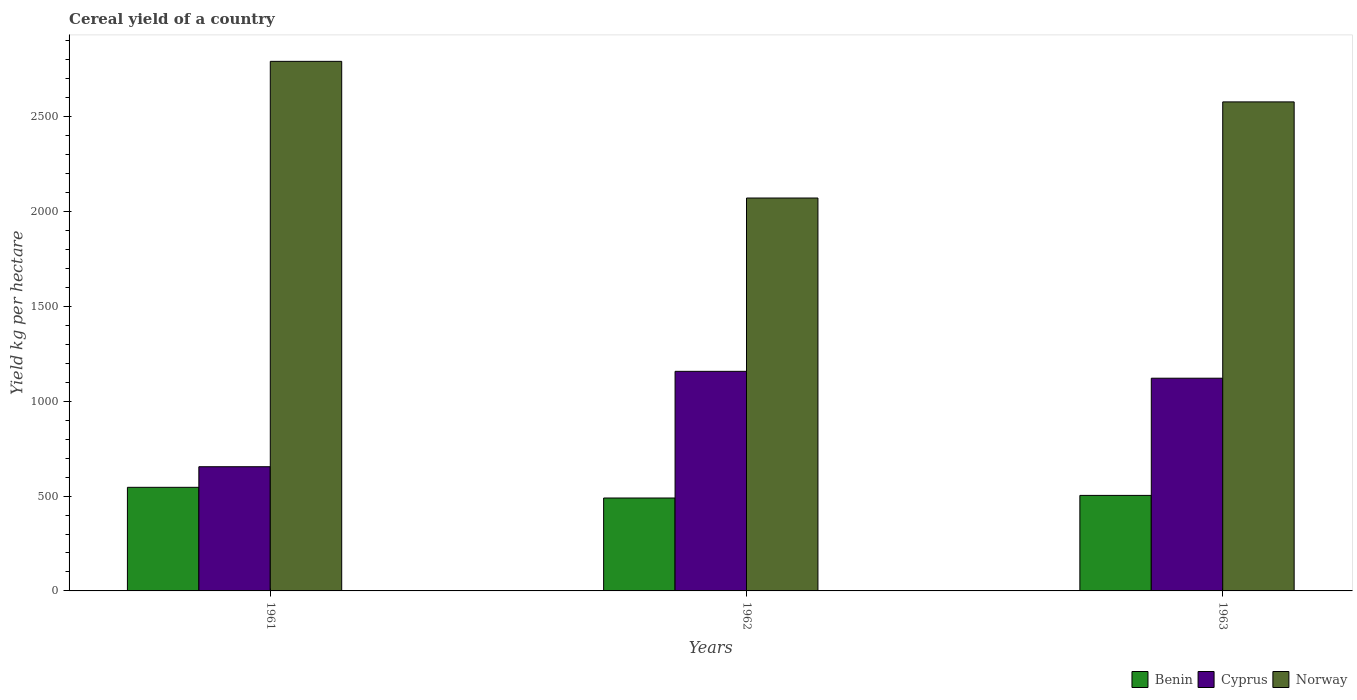How many different coloured bars are there?
Offer a very short reply. 3. Are the number of bars on each tick of the X-axis equal?
Offer a very short reply. Yes. How many bars are there on the 2nd tick from the left?
Your response must be concise. 3. What is the total cereal yield in Cyprus in 1962?
Your response must be concise. 1157.61. Across all years, what is the maximum total cereal yield in Norway?
Make the answer very short. 2791.78. Across all years, what is the minimum total cereal yield in Norway?
Ensure brevity in your answer.  2071.26. In which year was the total cereal yield in Cyprus maximum?
Provide a short and direct response. 1962. In which year was the total cereal yield in Benin minimum?
Offer a terse response. 1962. What is the total total cereal yield in Benin in the graph?
Give a very brief answer. 1539.53. What is the difference between the total cereal yield in Benin in 1961 and that in 1963?
Ensure brevity in your answer.  42.59. What is the difference between the total cereal yield in Benin in 1962 and the total cereal yield in Cyprus in 1963?
Offer a terse response. -631.47. What is the average total cereal yield in Norway per year?
Ensure brevity in your answer.  2480.37. In the year 1961, what is the difference between the total cereal yield in Benin and total cereal yield in Norway?
Offer a terse response. -2245.65. In how many years, is the total cereal yield in Cyprus greater than 1900 kg per hectare?
Offer a terse response. 0. What is the ratio of the total cereal yield in Benin in 1962 to that in 1963?
Your response must be concise. 0.97. Is the difference between the total cereal yield in Benin in 1962 and 1963 greater than the difference between the total cereal yield in Norway in 1962 and 1963?
Provide a succinct answer. Yes. What is the difference between the highest and the second highest total cereal yield in Benin?
Offer a terse response. 42.59. What is the difference between the highest and the lowest total cereal yield in Benin?
Provide a short and direct response. 56.27. In how many years, is the total cereal yield in Cyprus greater than the average total cereal yield in Cyprus taken over all years?
Make the answer very short. 2. Is the sum of the total cereal yield in Benin in 1961 and 1963 greater than the maximum total cereal yield in Norway across all years?
Provide a short and direct response. No. What does the 1st bar from the left in 1961 represents?
Provide a succinct answer. Benin. What does the 2nd bar from the right in 1962 represents?
Keep it short and to the point. Cyprus. Is it the case that in every year, the sum of the total cereal yield in Cyprus and total cereal yield in Benin is greater than the total cereal yield in Norway?
Ensure brevity in your answer.  No. How many bars are there?
Offer a terse response. 9. How many years are there in the graph?
Offer a very short reply. 3. Are the values on the major ticks of Y-axis written in scientific E-notation?
Provide a succinct answer. No. Does the graph contain grids?
Your answer should be compact. No. How many legend labels are there?
Your response must be concise. 3. What is the title of the graph?
Make the answer very short. Cereal yield of a country. What is the label or title of the X-axis?
Your answer should be very brief. Years. What is the label or title of the Y-axis?
Provide a succinct answer. Yield kg per hectare. What is the Yield kg per hectare of Benin in 1961?
Offer a very short reply. 546.13. What is the Yield kg per hectare of Cyprus in 1961?
Your response must be concise. 654.75. What is the Yield kg per hectare in Norway in 1961?
Give a very brief answer. 2791.78. What is the Yield kg per hectare of Benin in 1962?
Provide a succinct answer. 489.86. What is the Yield kg per hectare in Cyprus in 1962?
Keep it short and to the point. 1157.61. What is the Yield kg per hectare in Norway in 1962?
Offer a very short reply. 2071.26. What is the Yield kg per hectare of Benin in 1963?
Offer a terse response. 503.54. What is the Yield kg per hectare in Cyprus in 1963?
Offer a very short reply. 1121.33. What is the Yield kg per hectare of Norway in 1963?
Your answer should be compact. 2578.06. Across all years, what is the maximum Yield kg per hectare in Benin?
Ensure brevity in your answer.  546.13. Across all years, what is the maximum Yield kg per hectare of Cyprus?
Offer a very short reply. 1157.61. Across all years, what is the maximum Yield kg per hectare of Norway?
Your response must be concise. 2791.78. Across all years, what is the minimum Yield kg per hectare of Benin?
Your answer should be very brief. 489.86. Across all years, what is the minimum Yield kg per hectare of Cyprus?
Make the answer very short. 654.75. Across all years, what is the minimum Yield kg per hectare in Norway?
Give a very brief answer. 2071.26. What is the total Yield kg per hectare of Benin in the graph?
Your response must be concise. 1539.54. What is the total Yield kg per hectare in Cyprus in the graph?
Provide a short and direct response. 2933.7. What is the total Yield kg per hectare in Norway in the graph?
Ensure brevity in your answer.  7441.1. What is the difference between the Yield kg per hectare of Benin in 1961 and that in 1962?
Your answer should be compact. 56.27. What is the difference between the Yield kg per hectare in Cyprus in 1961 and that in 1962?
Provide a succinct answer. -502.86. What is the difference between the Yield kg per hectare in Norway in 1961 and that in 1962?
Offer a very short reply. 720.52. What is the difference between the Yield kg per hectare of Benin in 1961 and that in 1963?
Ensure brevity in your answer.  42.59. What is the difference between the Yield kg per hectare in Cyprus in 1961 and that in 1963?
Provide a succinct answer. -466.57. What is the difference between the Yield kg per hectare of Norway in 1961 and that in 1963?
Your answer should be compact. 213.72. What is the difference between the Yield kg per hectare in Benin in 1962 and that in 1963?
Ensure brevity in your answer.  -13.68. What is the difference between the Yield kg per hectare of Cyprus in 1962 and that in 1963?
Provide a succinct answer. 36.28. What is the difference between the Yield kg per hectare in Norway in 1962 and that in 1963?
Offer a terse response. -506.8. What is the difference between the Yield kg per hectare of Benin in 1961 and the Yield kg per hectare of Cyprus in 1962?
Ensure brevity in your answer.  -611.48. What is the difference between the Yield kg per hectare of Benin in 1961 and the Yield kg per hectare of Norway in 1962?
Your answer should be very brief. -1525.13. What is the difference between the Yield kg per hectare of Cyprus in 1961 and the Yield kg per hectare of Norway in 1962?
Keep it short and to the point. -1416.51. What is the difference between the Yield kg per hectare in Benin in 1961 and the Yield kg per hectare in Cyprus in 1963?
Provide a succinct answer. -575.2. What is the difference between the Yield kg per hectare of Benin in 1961 and the Yield kg per hectare of Norway in 1963?
Offer a very short reply. -2031.92. What is the difference between the Yield kg per hectare of Cyprus in 1961 and the Yield kg per hectare of Norway in 1963?
Your answer should be compact. -1923.3. What is the difference between the Yield kg per hectare of Benin in 1962 and the Yield kg per hectare of Cyprus in 1963?
Provide a succinct answer. -631.47. What is the difference between the Yield kg per hectare of Benin in 1962 and the Yield kg per hectare of Norway in 1963?
Your answer should be compact. -2088.2. What is the difference between the Yield kg per hectare of Cyprus in 1962 and the Yield kg per hectare of Norway in 1963?
Give a very brief answer. -1420.45. What is the average Yield kg per hectare of Benin per year?
Make the answer very short. 513.18. What is the average Yield kg per hectare in Cyprus per year?
Offer a very short reply. 977.9. What is the average Yield kg per hectare of Norway per year?
Keep it short and to the point. 2480.37. In the year 1961, what is the difference between the Yield kg per hectare in Benin and Yield kg per hectare in Cyprus?
Your answer should be very brief. -108.62. In the year 1961, what is the difference between the Yield kg per hectare in Benin and Yield kg per hectare in Norway?
Offer a terse response. -2245.65. In the year 1961, what is the difference between the Yield kg per hectare of Cyprus and Yield kg per hectare of Norway?
Offer a terse response. -2137.03. In the year 1962, what is the difference between the Yield kg per hectare in Benin and Yield kg per hectare in Cyprus?
Offer a terse response. -667.75. In the year 1962, what is the difference between the Yield kg per hectare in Benin and Yield kg per hectare in Norway?
Give a very brief answer. -1581.4. In the year 1962, what is the difference between the Yield kg per hectare in Cyprus and Yield kg per hectare in Norway?
Give a very brief answer. -913.65. In the year 1963, what is the difference between the Yield kg per hectare in Benin and Yield kg per hectare in Cyprus?
Your answer should be compact. -617.79. In the year 1963, what is the difference between the Yield kg per hectare in Benin and Yield kg per hectare in Norway?
Offer a very short reply. -2074.52. In the year 1963, what is the difference between the Yield kg per hectare in Cyprus and Yield kg per hectare in Norway?
Offer a terse response. -1456.73. What is the ratio of the Yield kg per hectare of Benin in 1961 to that in 1962?
Give a very brief answer. 1.11. What is the ratio of the Yield kg per hectare of Cyprus in 1961 to that in 1962?
Your answer should be very brief. 0.57. What is the ratio of the Yield kg per hectare of Norway in 1961 to that in 1962?
Make the answer very short. 1.35. What is the ratio of the Yield kg per hectare of Benin in 1961 to that in 1963?
Make the answer very short. 1.08. What is the ratio of the Yield kg per hectare in Cyprus in 1961 to that in 1963?
Offer a very short reply. 0.58. What is the ratio of the Yield kg per hectare of Norway in 1961 to that in 1963?
Your answer should be compact. 1.08. What is the ratio of the Yield kg per hectare in Benin in 1962 to that in 1963?
Keep it short and to the point. 0.97. What is the ratio of the Yield kg per hectare in Cyprus in 1962 to that in 1963?
Make the answer very short. 1.03. What is the ratio of the Yield kg per hectare of Norway in 1962 to that in 1963?
Make the answer very short. 0.8. What is the difference between the highest and the second highest Yield kg per hectare of Benin?
Your response must be concise. 42.59. What is the difference between the highest and the second highest Yield kg per hectare in Cyprus?
Your answer should be very brief. 36.28. What is the difference between the highest and the second highest Yield kg per hectare in Norway?
Offer a very short reply. 213.72. What is the difference between the highest and the lowest Yield kg per hectare in Benin?
Make the answer very short. 56.27. What is the difference between the highest and the lowest Yield kg per hectare of Cyprus?
Offer a terse response. 502.86. What is the difference between the highest and the lowest Yield kg per hectare of Norway?
Keep it short and to the point. 720.52. 